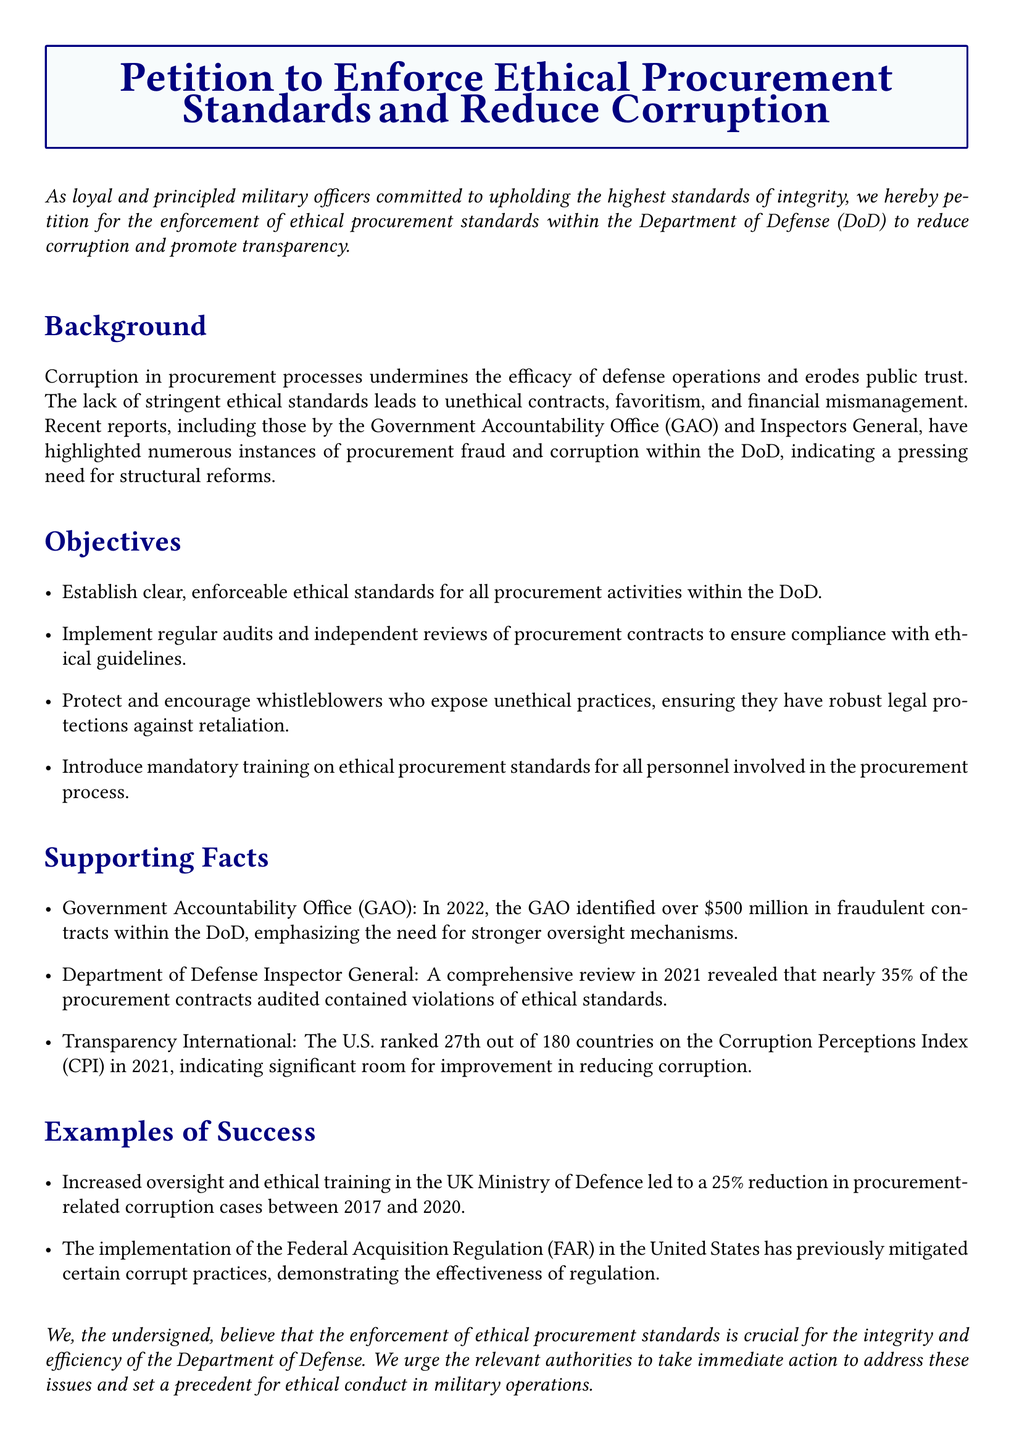What is the title of the petition? The title is explicitly stated at the beginning of the document and is "Petition to Enforce Ethical Procurement Standards and Reduce Corruption."
Answer: Petition to Enforce Ethical Procurement Standards and Reduce Corruption What organization is the petition directed towards? The petition specifies that it is directed towards the "Department of Defense (DoD)" in the introduction.
Answer: Department of Defense (DoD) How much fraudulent contracts did the GAO identify in 2022? The document provides a specific figure from the GAO's report regarding fraudulent contracts identified in 2022.
Answer: $500 million What percentage of procurement contracts audited contained violations of ethical standards? This information is detailed in the paragraph from the Department of Defense Inspector General.
Answer: 35% What is one objective of the petition? The objectives are listed in a bulleted format, one example of an objective is requested in the question.
Answer: Establish clear, enforceable ethical standards for all procurement activities within the DoD What ranking did the U.S. achieve in the Corruption Perceptions Index in 2021? The document mentions the specific rank obtained by the U.S. in the Corruption Perceptions Index.
Answer: 27th Which country experienced a reduction in procurement-related corruption cases due to increased oversight and training? The document includes an example of a country that successfully implemented ethical training and oversight measures.
Answer: UK What year did the implementation of the Federal Acquisition Regulation occur? The document refers to the Federal Acquisition Regulation (FAR) in relation to its previous effectiveness in mitigating corruption.
Answer: Not specified in the document 